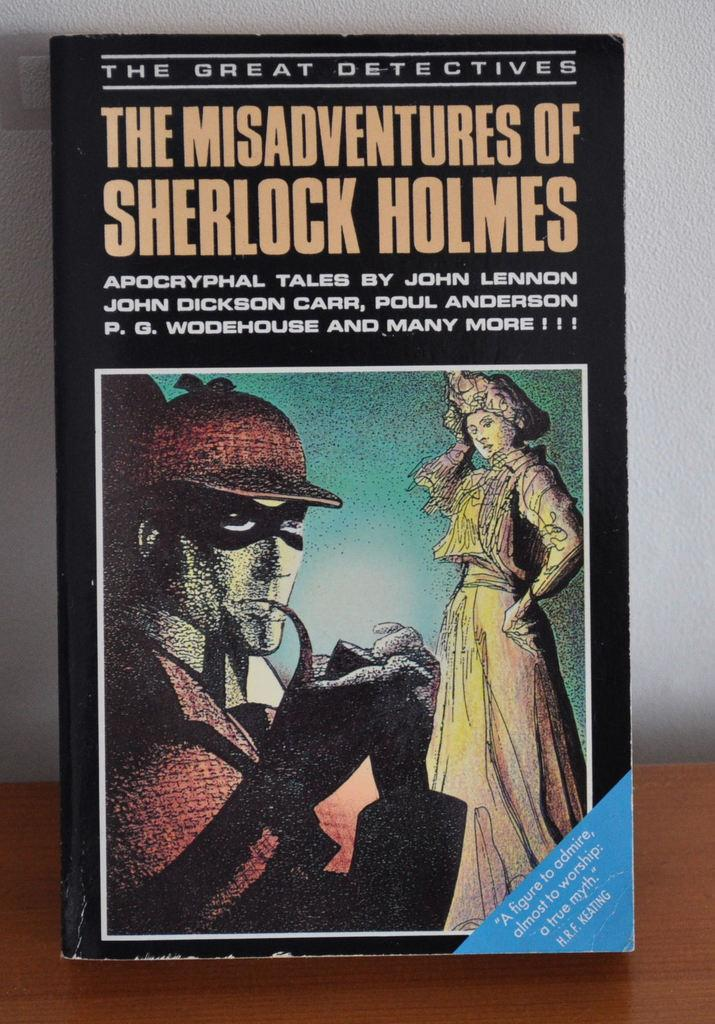<image>
Create a compact narrative representing the image presented. A book called The Misadventures of Sherlock Holmes. 